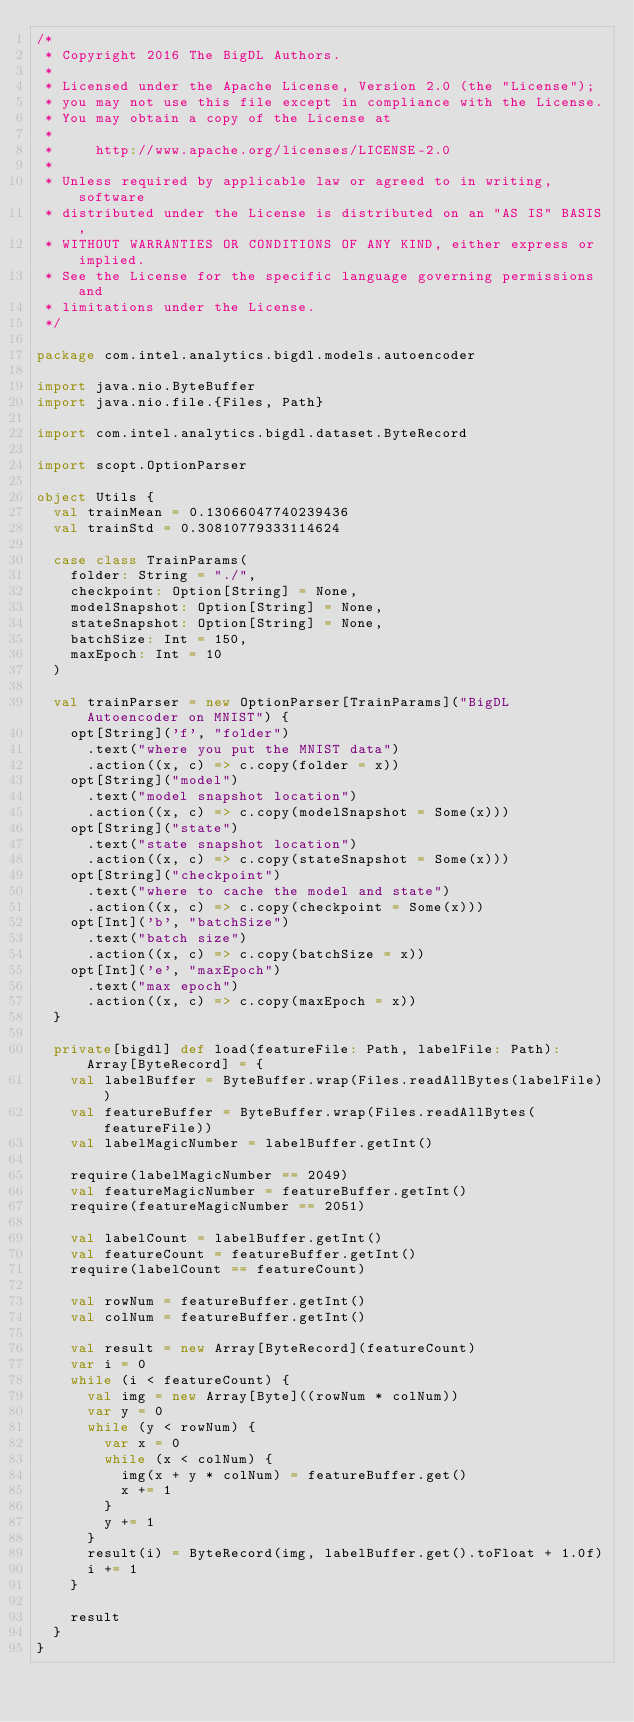<code> <loc_0><loc_0><loc_500><loc_500><_Scala_>/*
 * Copyright 2016 The BigDL Authors.
 *
 * Licensed under the Apache License, Version 2.0 (the "License");
 * you may not use this file except in compliance with the License.
 * You may obtain a copy of the License at
 *
 *     http://www.apache.org/licenses/LICENSE-2.0
 *
 * Unless required by applicable law or agreed to in writing, software
 * distributed under the License is distributed on an "AS IS" BASIS,
 * WITHOUT WARRANTIES OR CONDITIONS OF ANY KIND, either express or implied.
 * See the License for the specific language governing permissions and
 * limitations under the License.
 */

package com.intel.analytics.bigdl.models.autoencoder

import java.nio.ByteBuffer
import java.nio.file.{Files, Path}

import com.intel.analytics.bigdl.dataset.ByteRecord

import scopt.OptionParser

object Utils {
  val trainMean = 0.13066047740239436
  val trainStd = 0.30810779333114624

  case class TrainParams(
    folder: String = "./",
    checkpoint: Option[String] = None,
    modelSnapshot: Option[String] = None,
    stateSnapshot: Option[String] = None,
    batchSize: Int = 150,
    maxEpoch: Int = 10
  )

  val trainParser = new OptionParser[TrainParams]("BigDL Autoencoder on MNIST") {
    opt[String]('f', "folder")
      .text("where you put the MNIST data")
      .action((x, c) => c.copy(folder = x))
    opt[String]("model")
      .text("model snapshot location")
      .action((x, c) => c.copy(modelSnapshot = Some(x)))
    opt[String]("state")
      .text("state snapshot location")
      .action((x, c) => c.copy(stateSnapshot = Some(x)))
    opt[String]("checkpoint")
      .text("where to cache the model and state")
      .action((x, c) => c.copy(checkpoint = Some(x)))
    opt[Int]('b', "batchSize")
      .text("batch size")
      .action((x, c) => c.copy(batchSize = x))
    opt[Int]('e', "maxEpoch")
      .text("max epoch")
      .action((x, c) => c.copy(maxEpoch = x))
  }

  private[bigdl] def load(featureFile: Path, labelFile: Path): Array[ByteRecord] = {
    val labelBuffer = ByteBuffer.wrap(Files.readAllBytes(labelFile))
    val featureBuffer = ByteBuffer.wrap(Files.readAllBytes(featureFile))
    val labelMagicNumber = labelBuffer.getInt()

    require(labelMagicNumber == 2049)
    val featureMagicNumber = featureBuffer.getInt()
    require(featureMagicNumber == 2051)

    val labelCount = labelBuffer.getInt()
    val featureCount = featureBuffer.getInt()
    require(labelCount == featureCount)

    val rowNum = featureBuffer.getInt()
    val colNum = featureBuffer.getInt()

    val result = new Array[ByteRecord](featureCount)
    var i = 0
    while (i < featureCount) {
      val img = new Array[Byte]((rowNum * colNum))
      var y = 0
      while (y < rowNum) {
        var x = 0
        while (x < colNum) {
          img(x + y * colNum) = featureBuffer.get()
          x += 1
        }
        y += 1
      }
      result(i) = ByteRecord(img, labelBuffer.get().toFloat + 1.0f)
      i += 1
    }

    result
  }
}
</code> 